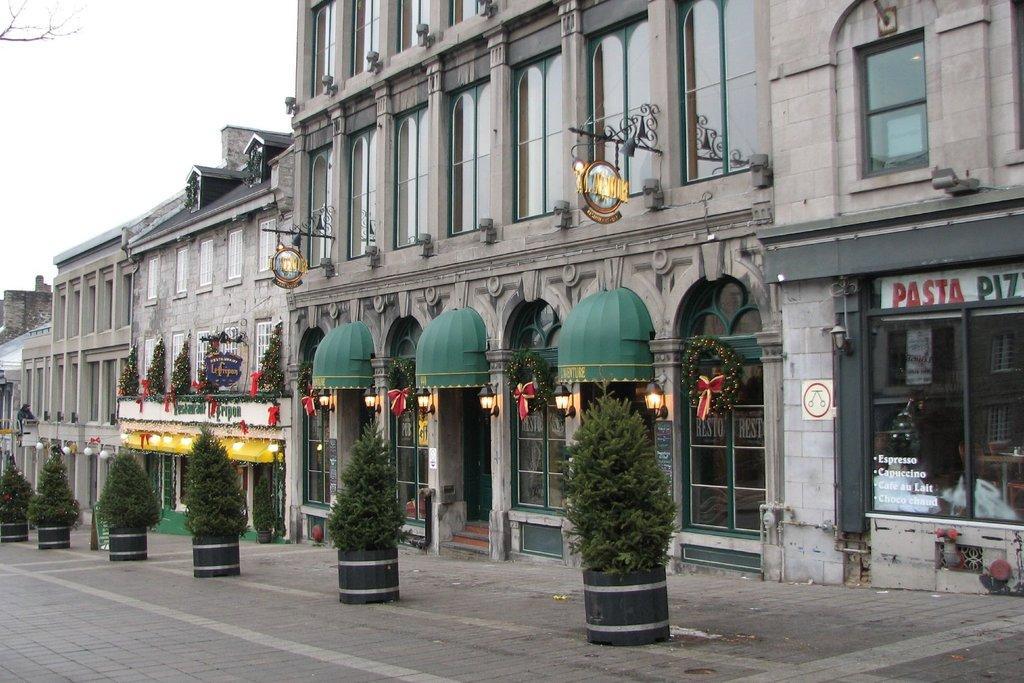Describe this image in one or two sentences. In this image we can see few buildings, there are few plants in front of the buildings, we can see few lights and decorative items on the buildings, there are glass windows, we can see sky and there is a branch of a tree. 